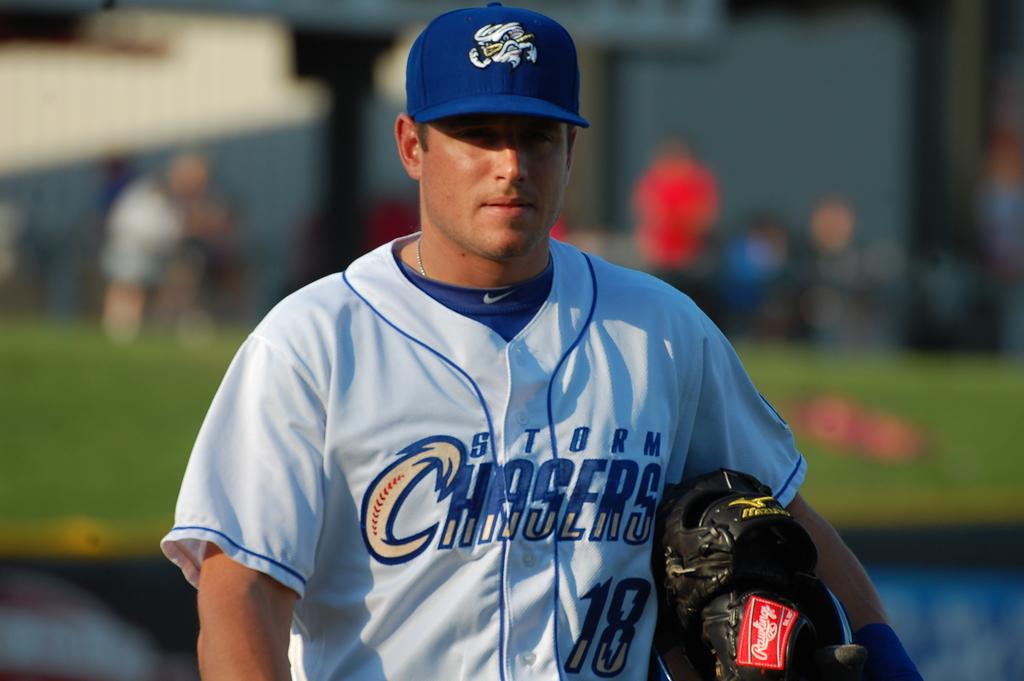What team does the player play for?
Provide a succinct answer. Storm chasers. What number is on his jersey?
Your response must be concise. 18. 